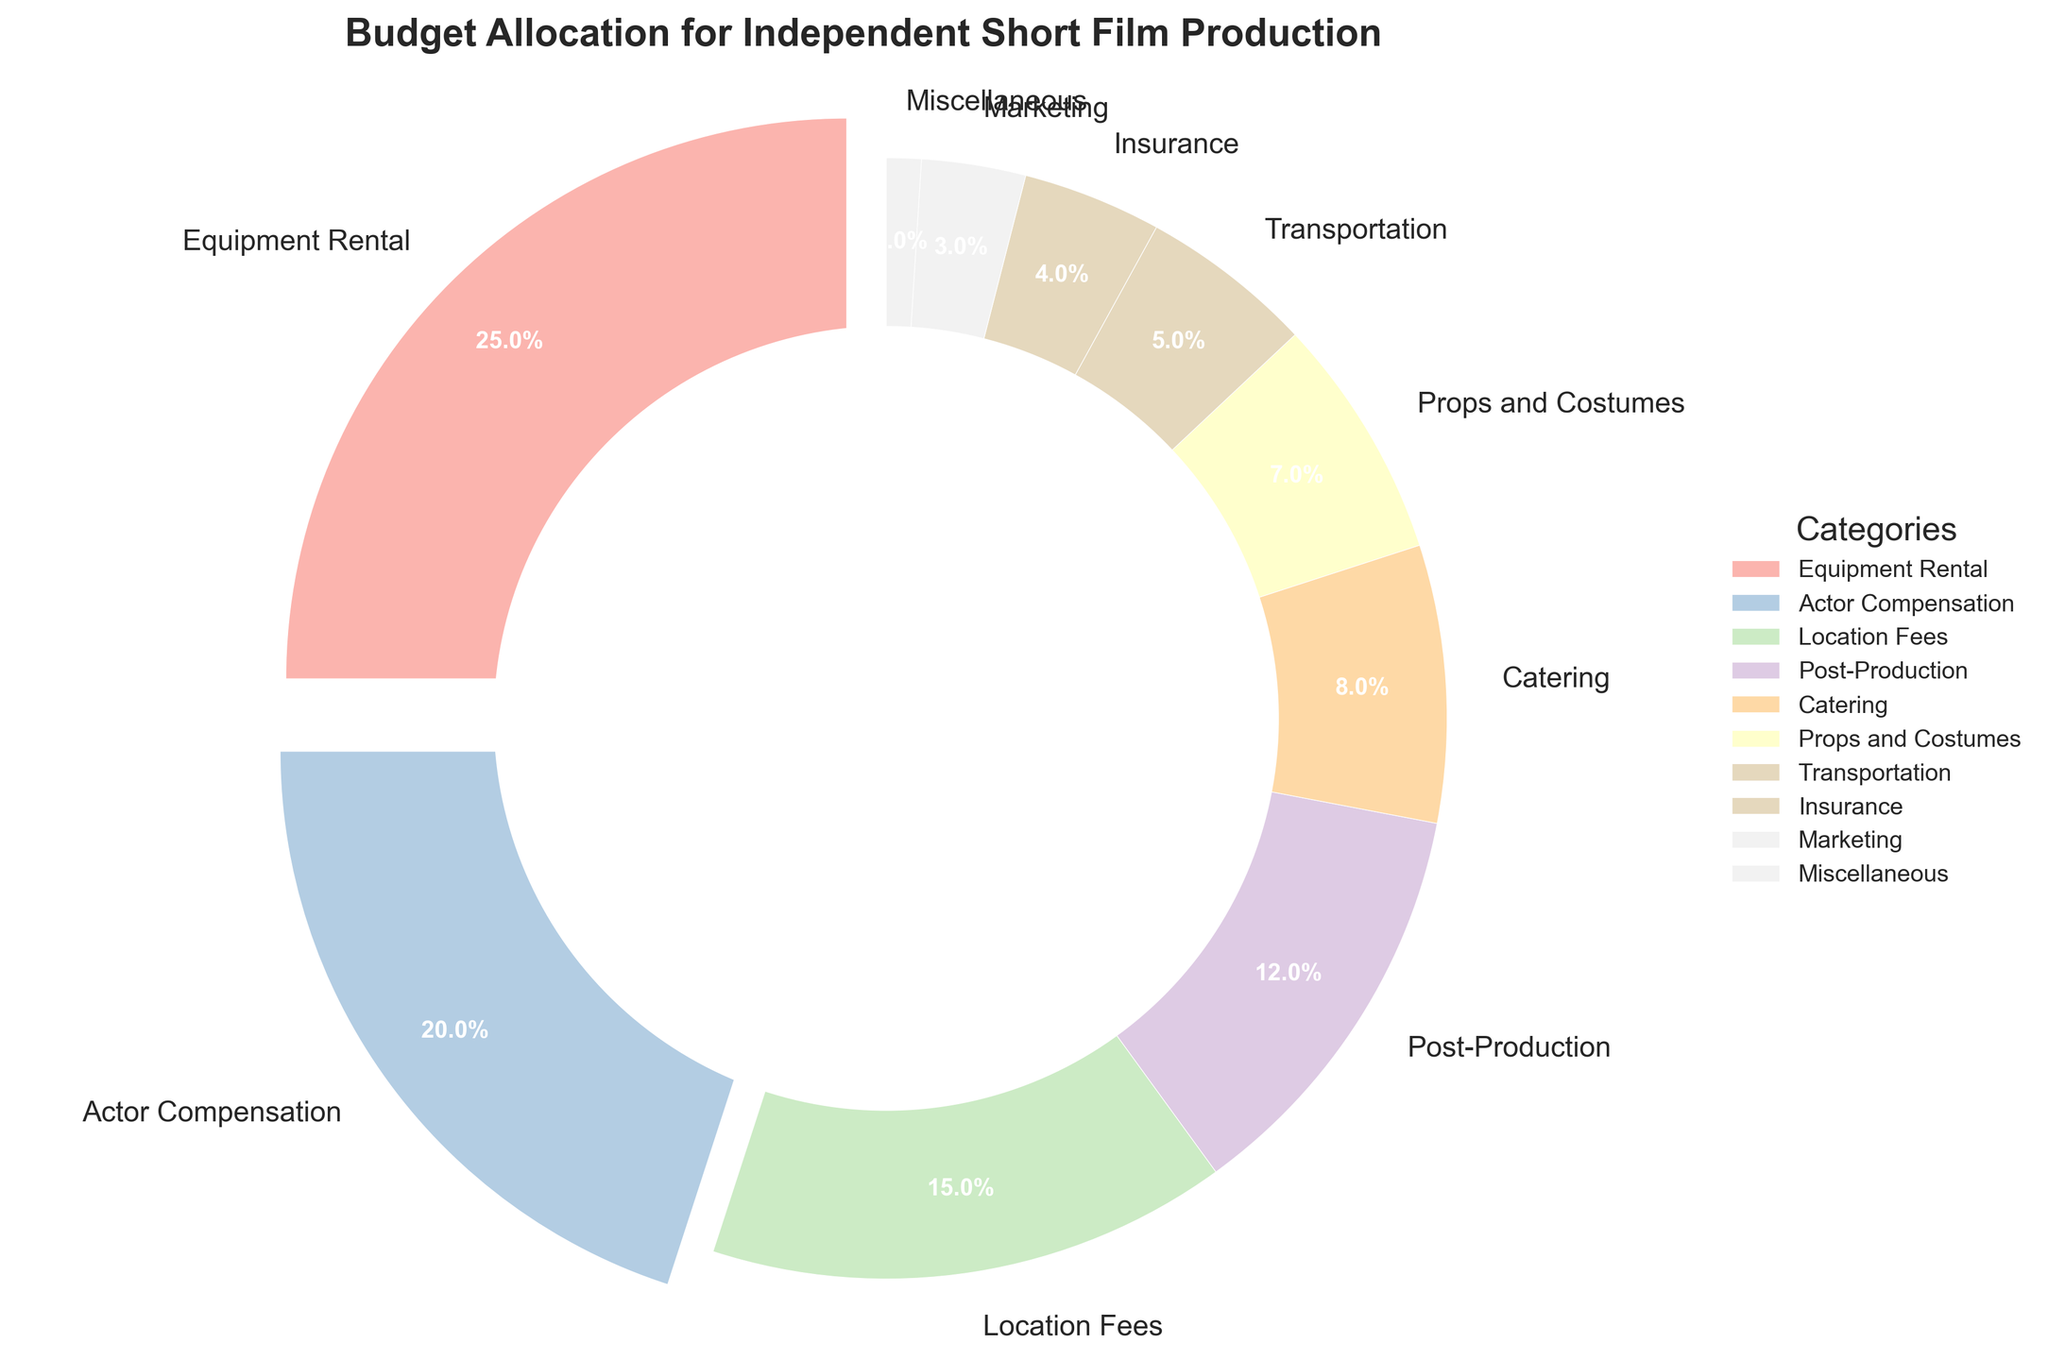What percentage of the budget is allocated to the top three categories? The top three categories by percentage are Equipment Rental (25%), Actor Compensation (20%), and Location Fees (15%). Summing these values, 25% + 20% + 15% = 60%.
Answer: 60% Which category has the smallest budget allocation, and what is its percentage? The category with the smallest budget allocation is Miscellaneous with 1%.
Answer: Miscellaneous, 1% How much more is allocated to Equipment Rental compared to Post-Production? Equipment Rental is allocated 25%, and Post-Production is allocated 12%. The difference between these percentages is 25% - 12% = 13%.
Answer: 13% Is more budget allocated to Actor Compensation or Location Fees? Actor Compensation is allocated 20%, while Location Fees are allocated 15%. Therefore, Actor Compensation has a higher allocation.
Answer: Actor Compensation Which category has a budget allocation closest to 10%? Post-Production has the closest allocation to 10%, with a percentage of 12%.
Answer: Post-Production What is the combined percentage of the categories with a budget allocation of less than 10%? Categories with less than 10% allocation are Catering (8%), Props and Costumes (7%), Transportation (5%), Insurance (4%), Marketing (3%), and Miscellaneous (1%). Adding these values: 8% + 7% + 5% + 4% + 3% + 1% = 28%.
Answer: 28% Which two categories together have a higher budget allocation than Actor Compensation? Categories that need to be combined are less than Actor Compensation (20%). Post-Production (12%) and Catering (8%) together equal 12% + 8% = 20%. Props and Costumes (7%) and Transportation (5%) together are 7% + 5% = 12%, less than Actor Compensation.
Answer: Post-Production and Catering, 20% What visual attribute indicates the category with the highest budget allocation? The category with the highest budget allocation, Equipment Rental, is marked with a larger wedge that is also exploded slightly outward compared to others.
Answer: Larger and exploded wedge 